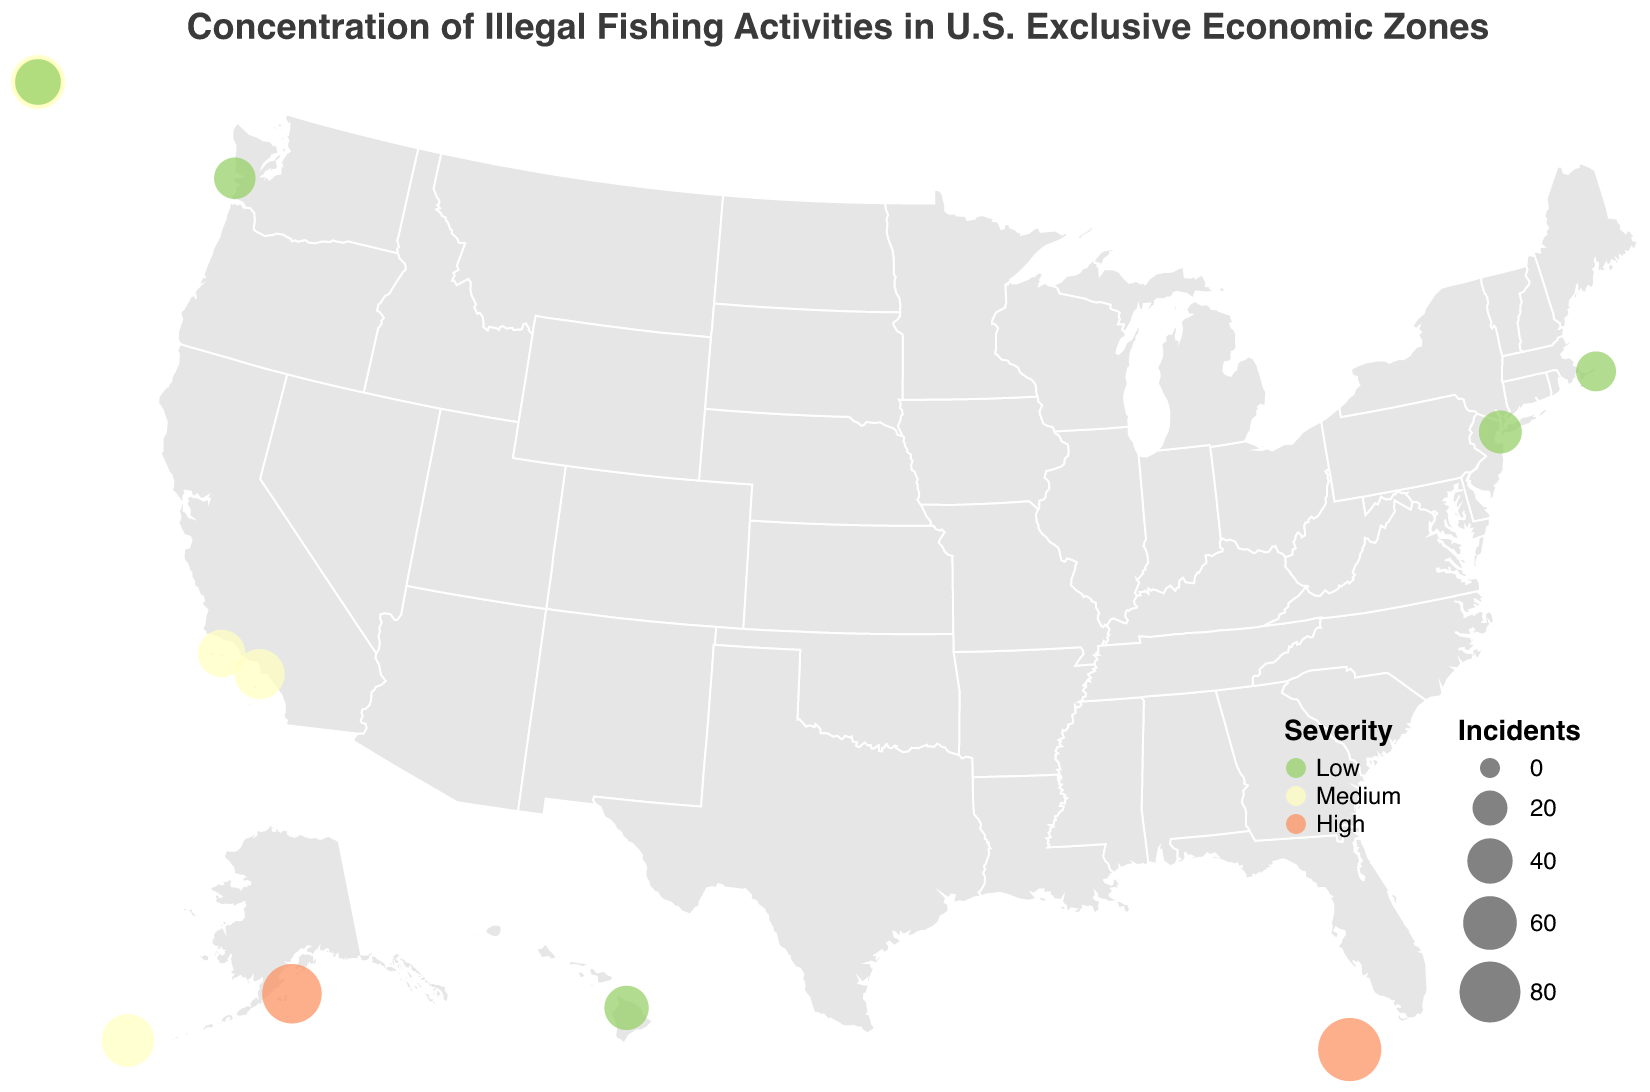What's the title of the figure? The title is displayed at the top center of the figure. It reads "Concentration of Illegal Fishing Activities in U.S. Exclusive Economic Zones".
Answer: Concentration of Illegal Fishing Activities in U.S. Exclusive Economic Zones How many locations are shown on the map? By counting the number of data points (circles) on the map, we can see that there are 12 locations represented.
Answer: 12 Which location has the highest number of incidents? By looking at the size of the circles, the Florida Keys has the largest circle indicating the highest number of incidents.
Answer: Florida Keys Which locations are classified as having "High" severity incidents? The locations with orange circles represent high severity. These are the Florida Keys and Kodiak Island.
Answer: Florida Keys, Kodiak Island Which location has the smallest number of incidents? By comparing the size of the circles, Georges Bank has the smallest circle, representing the fewest incidents.
Answer: Georges Bank What is the total number of incidents in locations classified as “Medium” severity? Summing up the incidents in medium-severity locations: U.S. Virgin Islands (62) + Guam (53) + Aleutian Islands (58) + Channel Islands (45) + Southern California (51) = 269.
Answer: 269 Compare the number of incidents between Big Island Hawaii and Southern California. Which one has more? By comparing the sizes of the circles, Southern California (51 incidents) has more incidents than Big Island Hawaii (38 incidents).
Answer: Southern California List all the locations with low-severity incidents and their corresponding number of incidents. The locations with green circles represent low severity: Hawaiian Islands (41), New York Bight (35), Georges Bank (29), Washington Coast (32), Big Island Hawaii (38).
Answer: Hawaiian Islands (41), New York Bight (35), Georges Bank (29), Washington Coast (32), Big Island Hawaii (38) What is the average number of incidents among all locations? Summing all the incidents: 87 + 62 + 53 + 41 + 35 + 29 + 76 + 58 + 32 + 45 + 38 + 51 = 607. Dividing by the number of locations (12), the average is 607 / 12 ≈ 50.58.
Answer: Approximately 50.58 Which locations are part of the U.S. West Coast and what are their severities? Washington Coast (Low), Channel Islands (Medium), and Southern California (Medium) are on the U.S. West Coast according to their geographic placements on the map.
Answer: Washington Coast (Low), Channel Islands (Medium), Southern California (Medium) 